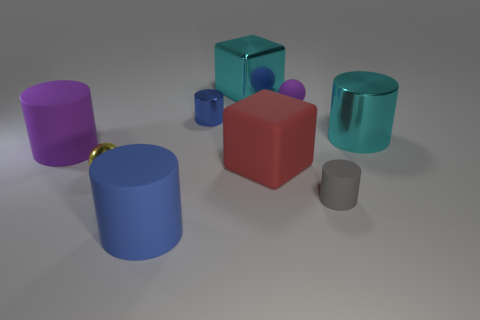Subtract all purple cylinders. How many cylinders are left? 4 Subtract 1 cylinders. How many cylinders are left? 4 Subtract all purple cylinders. How many cylinders are left? 4 Subtract all yellow cylinders. Subtract all blue balls. How many cylinders are left? 5 Add 1 blue cylinders. How many objects exist? 10 Subtract all cylinders. How many objects are left? 4 Subtract all small red shiny spheres. Subtract all big cyan shiny things. How many objects are left? 7 Add 3 small purple rubber balls. How many small purple rubber balls are left? 4 Add 1 brown things. How many brown things exist? 1 Subtract 0 yellow cylinders. How many objects are left? 9 